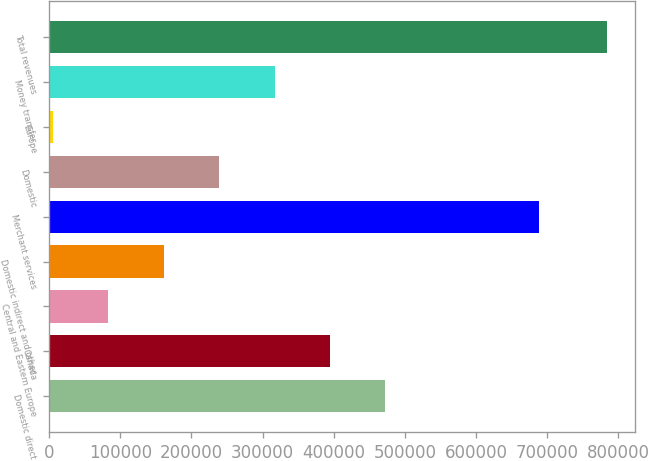Convert chart to OTSL. <chart><loc_0><loc_0><loc_500><loc_500><bar_chart><fcel>Domestic direct<fcel>Canada<fcel>Central and Eastern Europe<fcel>Domestic indirect and other<fcel>Merchant services<fcel>Domestic<fcel>Europe<fcel>Money transfer<fcel>Total revenues<nl><fcel>472605<fcel>394673<fcel>82946.6<fcel>160878<fcel>687868<fcel>238810<fcel>5015<fcel>316741<fcel>784331<nl></chart> 